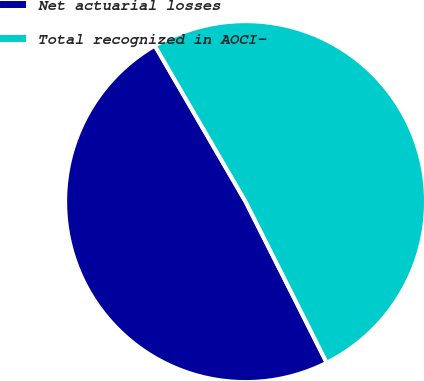Convert chart to OTSL. <chart><loc_0><loc_0><loc_500><loc_500><pie_chart><fcel>Net actuarial losses<fcel>Total recognized in AOCI-<nl><fcel>49.04%<fcel>50.96%<nl></chart> 